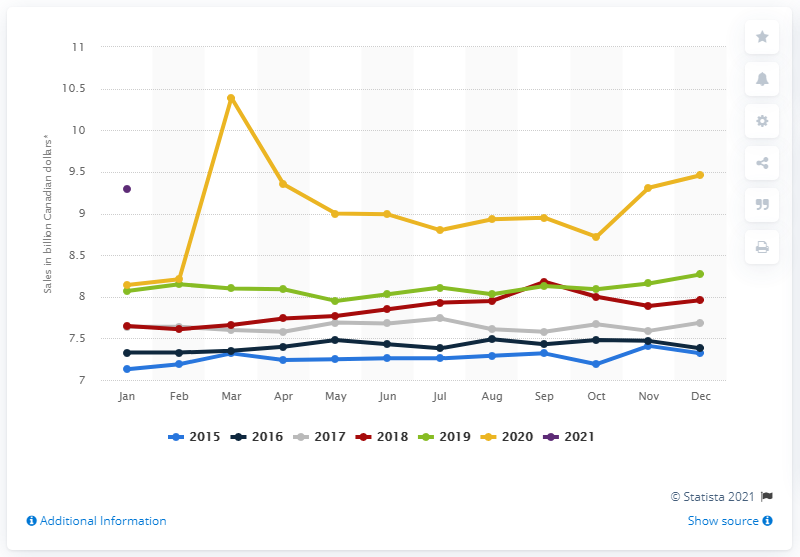What does the peak in sales in March 2020 correspond to? The peak in sales in March 2020 likely corresponds to the onset of the COVID-19 pandemic, where consumers may have engaged in panic buying or stockpiling groceries due to lockdown measures and uncertainty about the continuity of supplies. 